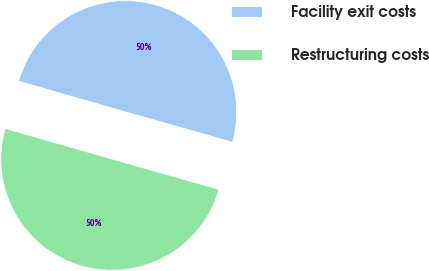Convert chart. <chart><loc_0><loc_0><loc_500><loc_500><pie_chart><fcel>Facility exit costs<fcel>Restructuring costs<nl><fcel>49.95%<fcel>50.05%<nl></chart> 